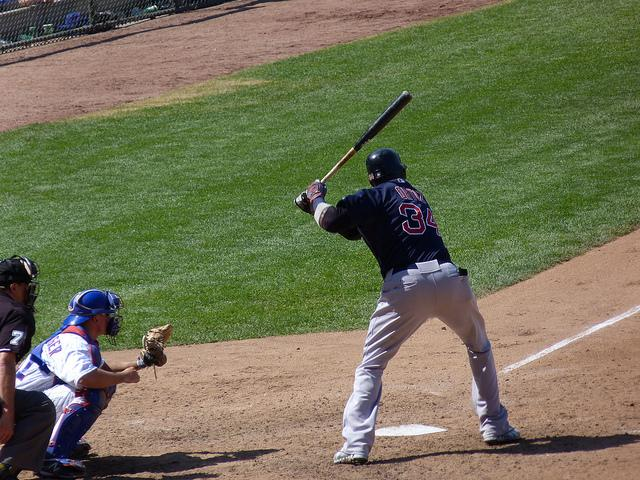What is the nickname of this player? batter 